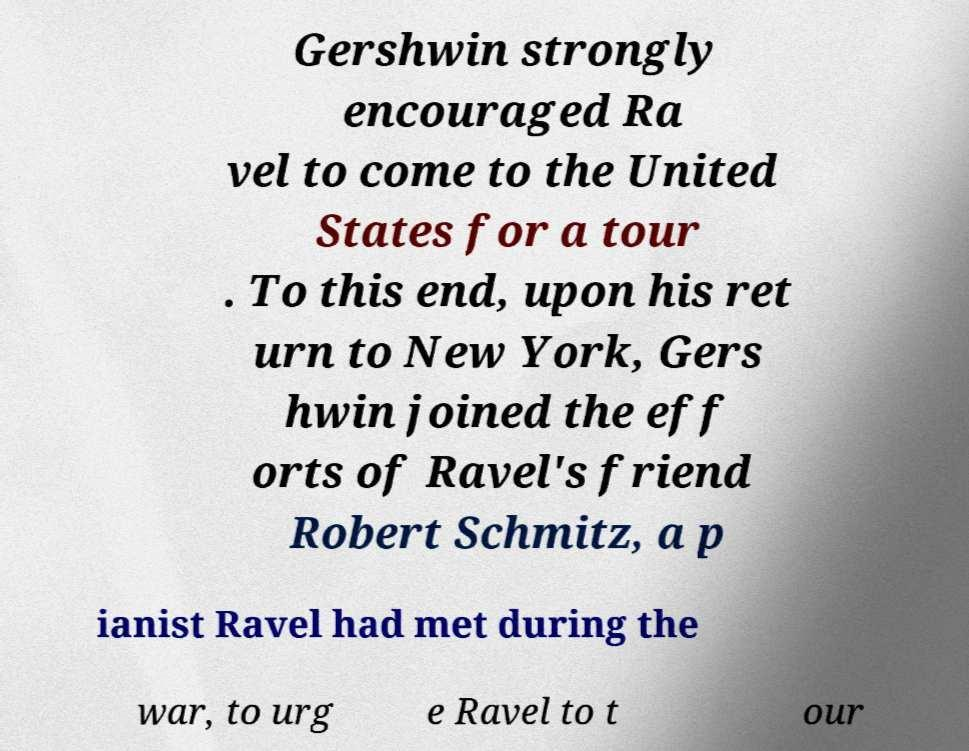Can you accurately transcribe the text from the provided image for me? Gershwin strongly encouraged Ra vel to come to the United States for a tour . To this end, upon his ret urn to New York, Gers hwin joined the eff orts of Ravel's friend Robert Schmitz, a p ianist Ravel had met during the war, to urg e Ravel to t our 